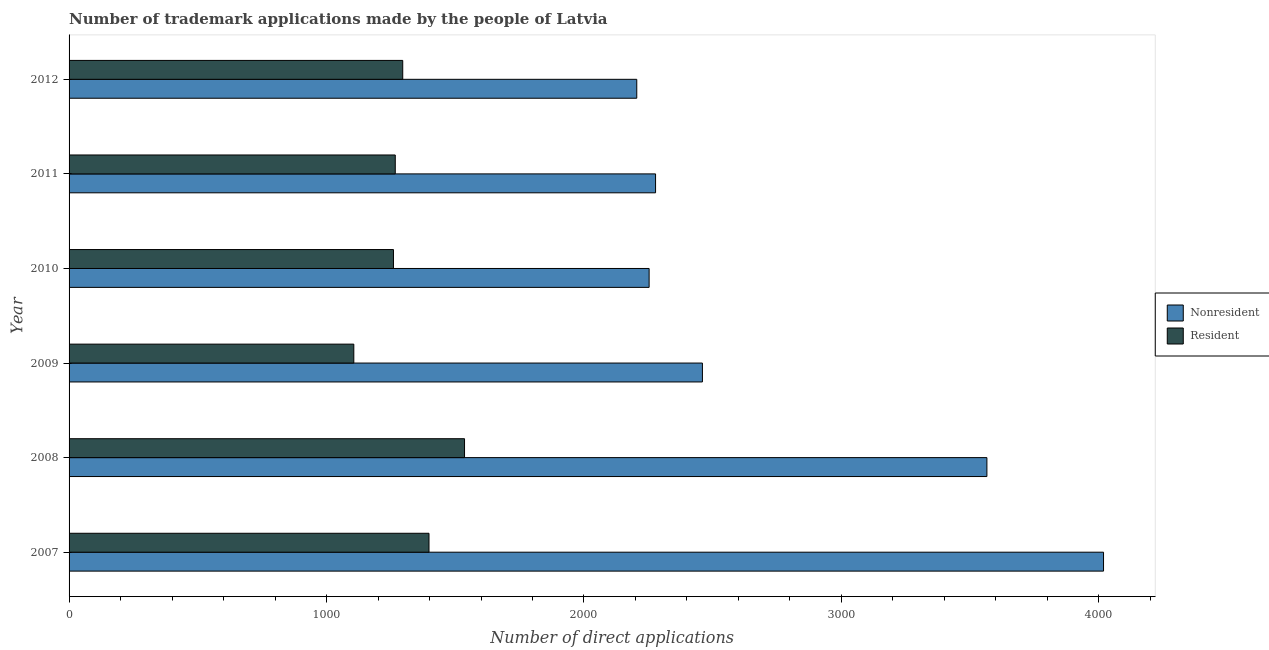How many groups of bars are there?
Ensure brevity in your answer.  6. What is the label of the 4th group of bars from the top?
Your response must be concise. 2009. What is the number of trademark applications made by residents in 2010?
Ensure brevity in your answer.  1260. Across all years, what is the maximum number of trademark applications made by residents?
Your answer should be very brief. 1536. Across all years, what is the minimum number of trademark applications made by residents?
Your response must be concise. 1106. In which year was the number of trademark applications made by residents minimum?
Ensure brevity in your answer.  2009. What is the total number of trademark applications made by non residents in the graph?
Offer a very short reply. 1.68e+04. What is the difference between the number of trademark applications made by residents in 2008 and that in 2009?
Ensure brevity in your answer.  430. What is the difference between the number of trademark applications made by residents in 2008 and the number of trademark applications made by non residents in 2009?
Give a very brief answer. -924. What is the average number of trademark applications made by residents per year?
Provide a short and direct response. 1310.5. In the year 2009, what is the difference between the number of trademark applications made by residents and number of trademark applications made by non residents?
Provide a succinct answer. -1354. What is the ratio of the number of trademark applications made by residents in 2007 to that in 2011?
Provide a short and direct response. 1.1. Is the number of trademark applications made by non residents in 2007 less than that in 2012?
Provide a succinct answer. No. Is the difference between the number of trademark applications made by non residents in 2009 and 2010 greater than the difference between the number of trademark applications made by residents in 2009 and 2010?
Offer a terse response. Yes. What is the difference between the highest and the second highest number of trademark applications made by residents?
Provide a succinct answer. 138. What is the difference between the highest and the lowest number of trademark applications made by residents?
Give a very brief answer. 430. In how many years, is the number of trademark applications made by residents greater than the average number of trademark applications made by residents taken over all years?
Ensure brevity in your answer.  2. What does the 2nd bar from the top in 2012 represents?
Ensure brevity in your answer.  Nonresident. What does the 1st bar from the bottom in 2010 represents?
Your answer should be very brief. Nonresident. How many bars are there?
Keep it short and to the point. 12. Does the graph contain grids?
Your answer should be compact. No. Where does the legend appear in the graph?
Give a very brief answer. Center right. How many legend labels are there?
Keep it short and to the point. 2. How are the legend labels stacked?
Ensure brevity in your answer.  Vertical. What is the title of the graph?
Make the answer very short. Number of trademark applications made by the people of Latvia. Does "Commercial service imports" appear as one of the legend labels in the graph?
Offer a terse response. No. What is the label or title of the X-axis?
Provide a succinct answer. Number of direct applications. What is the Number of direct applications of Nonresident in 2007?
Make the answer very short. 4018. What is the Number of direct applications of Resident in 2007?
Give a very brief answer. 1398. What is the Number of direct applications of Nonresident in 2008?
Make the answer very short. 3565. What is the Number of direct applications of Resident in 2008?
Keep it short and to the point. 1536. What is the Number of direct applications of Nonresident in 2009?
Provide a succinct answer. 2460. What is the Number of direct applications in Resident in 2009?
Keep it short and to the point. 1106. What is the Number of direct applications in Nonresident in 2010?
Offer a terse response. 2253. What is the Number of direct applications in Resident in 2010?
Ensure brevity in your answer.  1260. What is the Number of direct applications in Nonresident in 2011?
Ensure brevity in your answer.  2278. What is the Number of direct applications of Resident in 2011?
Keep it short and to the point. 1267. What is the Number of direct applications of Nonresident in 2012?
Offer a terse response. 2205. What is the Number of direct applications of Resident in 2012?
Keep it short and to the point. 1296. Across all years, what is the maximum Number of direct applications in Nonresident?
Your answer should be very brief. 4018. Across all years, what is the maximum Number of direct applications in Resident?
Offer a terse response. 1536. Across all years, what is the minimum Number of direct applications of Nonresident?
Provide a succinct answer. 2205. Across all years, what is the minimum Number of direct applications of Resident?
Offer a terse response. 1106. What is the total Number of direct applications of Nonresident in the graph?
Offer a terse response. 1.68e+04. What is the total Number of direct applications in Resident in the graph?
Offer a terse response. 7863. What is the difference between the Number of direct applications of Nonresident in 2007 and that in 2008?
Ensure brevity in your answer.  453. What is the difference between the Number of direct applications of Resident in 2007 and that in 2008?
Offer a terse response. -138. What is the difference between the Number of direct applications in Nonresident in 2007 and that in 2009?
Your answer should be very brief. 1558. What is the difference between the Number of direct applications in Resident in 2007 and that in 2009?
Provide a short and direct response. 292. What is the difference between the Number of direct applications in Nonresident in 2007 and that in 2010?
Offer a very short reply. 1765. What is the difference between the Number of direct applications of Resident in 2007 and that in 2010?
Keep it short and to the point. 138. What is the difference between the Number of direct applications of Nonresident in 2007 and that in 2011?
Make the answer very short. 1740. What is the difference between the Number of direct applications in Resident in 2007 and that in 2011?
Give a very brief answer. 131. What is the difference between the Number of direct applications in Nonresident in 2007 and that in 2012?
Make the answer very short. 1813. What is the difference between the Number of direct applications of Resident in 2007 and that in 2012?
Your response must be concise. 102. What is the difference between the Number of direct applications of Nonresident in 2008 and that in 2009?
Make the answer very short. 1105. What is the difference between the Number of direct applications in Resident in 2008 and that in 2009?
Provide a short and direct response. 430. What is the difference between the Number of direct applications of Nonresident in 2008 and that in 2010?
Make the answer very short. 1312. What is the difference between the Number of direct applications in Resident in 2008 and that in 2010?
Your response must be concise. 276. What is the difference between the Number of direct applications of Nonresident in 2008 and that in 2011?
Keep it short and to the point. 1287. What is the difference between the Number of direct applications in Resident in 2008 and that in 2011?
Ensure brevity in your answer.  269. What is the difference between the Number of direct applications in Nonresident in 2008 and that in 2012?
Offer a very short reply. 1360. What is the difference between the Number of direct applications of Resident in 2008 and that in 2012?
Ensure brevity in your answer.  240. What is the difference between the Number of direct applications of Nonresident in 2009 and that in 2010?
Provide a succinct answer. 207. What is the difference between the Number of direct applications in Resident in 2009 and that in 2010?
Provide a succinct answer. -154. What is the difference between the Number of direct applications of Nonresident in 2009 and that in 2011?
Your answer should be compact. 182. What is the difference between the Number of direct applications of Resident in 2009 and that in 2011?
Provide a short and direct response. -161. What is the difference between the Number of direct applications in Nonresident in 2009 and that in 2012?
Keep it short and to the point. 255. What is the difference between the Number of direct applications in Resident in 2009 and that in 2012?
Offer a very short reply. -190. What is the difference between the Number of direct applications of Nonresident in 2010 and that in 2012?
Offer a very short reply. 48. What is the difference between the Number of direct applications of Resident in 2010 and that in 2012?
Provide a short and direct response. -36. What is the difference between the Number of direct applications in Nonresident in 2011 and that in 2012?
Offer a very short reply. 73. What is the difference between the Number of direct applications in Resident in 2011 and that in 2012?
Provide a short and direct response. -29. What is the difference between the Number of direct applications of Nonresident in 2007 and the Number of direct applications of Resident in 2008?
Make the answer very short. 2482. What is the difference between the Number of direct applications of Nonresident in 2007 and the Number of direct applications of Resident in 2009?
Keep it short and to the point. 2912. What is the difference between the Number of direct applications of Nonresident in 2007 and the Number of direct applications of Resident in 2010?
Give a very brief answer. 2758. What is the difference between the Number of direct applications in Nonresident in 2007 and the Number of direct applications in Resident in 2011?
Make the answer very short. 2751. What is the difference between the Number of direct applications of Nonresident in 2007 and the Number of direct applications of Resident in 2012?
Keep it short and to the point. 2722. What is the difference between the Number of direct applications of Nonresident in 2008 and the Number of direct applications of Resident in 2009?
Provide a short and direct response. 2459. What is the difference between the Number of direct applications in Nonresident in 2008 and the Number of direct applications in Resident in 2010?
Your answer should be compact. 2305. What is the difference between the Number of direct applications of Nonresident in 2008 and the Number of direct applications of Resident in 2011?
Make the answer very short. 2298. What is the difference between the Number of direct applications of Nonresident in 2008 and the Number of direct applications of Resident in 2012?
Make the answer very short. 2269. What is the difference between the Number of direct applications of Nonresident in 2009 and the Number of direct applications of Resident in 2010?
Make the answer very short. 1200. What is the difference between the Number of direct applications in Nonresident in 2009 and the Number of direct applications in Resident in 2011?
Keep it short and to the point. 1193. What is the difference between the Number of direct applications in Nonresident in 2009 and the Number of direct applications in Resident in 2012?
Offer a terse response. 1164. What is the difference between the Number of direct applications of Nonresident in 2010 and the Number of direct applications of Resident in 2011?
Offer a terse response. 986. What is the difference between the Number of direct applications of Nonresident in 2010 and the Number of direct applications of Resident in 2012?
Offer a very short reply. 957. What is the difference between the Number of direct applications of Nonresident in 2011 and the Number of direct applications of Resident in 2012?
Give a very brief answer. 982. What is the average Number of direct applications of Nonresident per year?
Keep it short and to the point. 2796.5. What is the average Number of direct applications of Resident per year?
Offer a terse response. 1310.5. In the year 2007, what is the difference between the Number of direct applications in Nonresident and Number of direct applications in Resident?
Provide a succinct answer. 2620. In the year 2008, what is the difference between the Number of direct applications of Nonresident and Number of direct applications of Resident?
Your response must be concise. 2029. In the year 2009, what is the difference between the Number of direct applications of Nonresident and Number of direct applications of Resident?
Give a very brief answer. 1354. In the year 2010, what is the difference between the Number of direct applications of Nonresident and Number of direct applications of Resident?
Provide a short and direct response. 993. In the year 2011, what is the difference between the Number of direct applications in Nonresident and Number of direct applications in Resident?
Keep it short and to the point. 1011. In the year 2012, what is the difference between the Number of direct applications of Nonresident and Number of direct applications of Resident?
Offer a very short reply. 909. What is the ratio of the Number of direct applications of Nonresident in 2007 to that in 2008?
Provide a succinct answer. 1.13. What is the ratio of the Number of direct applications in Resident in 2007 to that in 2008?
Provide a short and direct response. 0.91. What is the ratio of the Number of direct applications in Nonresident in 2007 to that in 2009?
Give a very brief answer. 1.63. What is the ratio of the Number of direct applications in Resident in 2007 to that in 2009?
Make the answer very short. 1.26. What is the ratio of the Number of direct applications of Nonresident in 2007 to that in 2010?
Your answer should be compact. 1.78. What is the ratio of the Number of direct applications in Resident in 2007 to that in 2010?
Offer a terse response. 1.11. What is the ratio of the Number of direct applications of Nonresident in 2007 to that in 2011?
Give a very brief answer. 1.76. What is the ratio of the Number of direct applications in Resident in 2007 to that in 2011?
Make the answer very short. 1.1. What is the ratio of the Number of direct applications of Nonresident in 2007 to that in 2012?
Give a very brief answer. 1.82. What is the ratio of the Number of direct applications in Resident in 2007 to that in 2012?
Keep it short and to the point. 1.08. What is the ratio of the Number of direct applications of Nonresident in 2008 to that in 2009?
Your answer should be compact. 1.45. What is the ratio of the Number of direct applications in Resident in 2008 to that in 2009?
Give a very brief answer. 1.39. What is the ratio of the Number of direct applications of Nonresident in 2008 to that in 2010?
Ensure brevity in your answer.  1.58. What is the ratio of the Number of direct applications in Resident in 2008 to that in 2010?
Make the answer very short. 1.22. What is the ratio of the Number of direct applications in Nonresident in 2008 to that in 2011?
Your response must be concise. 1.56. What is the ratio of the Number of direct applications of Resident in 2008 to that in 2011?
Keep it short and to the point. 1.21. What is the ratio of the Number of direct applications of Nonresident in 2008 to that in 2012?
Offer a terse response. 1.62. What is the ratio of the Number of direct applications of Resident in 2008 to that in 2012?
Your answer should be compact. 1.19. What is the ratio of the Number of direct applications in Nonresident in 2009 to that in 2010?
Provide a short and direct response. 1.09. What is the ratio of the Number of direct applications in Resident in 2009 to that in 2010?
Your answer should be very brief. 0.88. What is the ratio of the Number of direct applications of Nonresident in 2009 to that in 2011?
Your answer should be very brief. 1.08. What is the ratio of the Number of direct applications in Resident in 2009 to that in 2011?
Provide a short and direct response. 0.87. What is the ratio of the Number of direct applications of Nonresident in 2009 to that in 2012?
Ensure brevity in your answer.  1.12. What is the ratio of the Number of direct applications of Resident in 2009 to that in 2012?
Your answer should be very brief. 0.85. What is the ratio of the Number of direct applications in Resident in 2010 to that in 2011?
Offer a terse response. 0.99. What is the ratio of the Number of direct applications of Nonresident in 2010 to that in 2012?
Your response must be concise. 1.02. What is the ratio of the Number of direct applications of Resident in 2010 to that in 2012?
Make the answer very short. 0.97. What is the ratio of the Number of direct applications in Nonresident in 2011 to that in 2012?
Ensure brevity in your answer.  1.03. What is the ratio of the Number of direct applications of Resident in 2011 to that in 2012?
Provide a short and direct response. 0.98. What is the difference between the highest and the second highest Number of direct applications in Nonresident?
Your response must be concise. 453. What is the difference between the highest and the second highest Number of direct applications in Resident?
Offer a terse response. 138. What is the difference between the highest and the lowest Number of direct applications of Nonresident?
Provide a succinct answer. 1813. What is the difference between the highest and the lowest Number of direct applications of Resident?
Give a very brief answer. 430. 